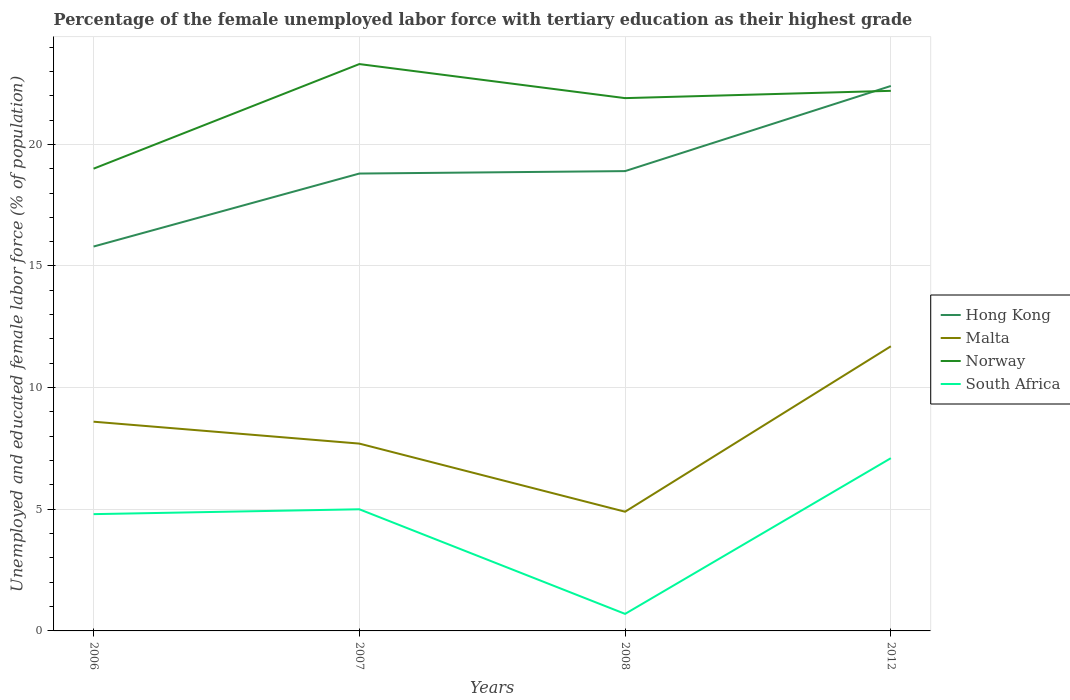Does the line corresponding to Malta intersect with the line corresponding to South Africa?
Keep it short and to the point. No. What is the total percentage of the unemployed female labor force with tertiary education in Malta in the graph?
Offer a terse response. -3.1. What is the difference between the highest and the second highest percentage of the unemployed female labor force with tertiary education in Malta?
Your response must be concise. 6.8. What is the difference between the highest and the lowest percentage of the unemployed female labor force with tertiary education in Hong Kong?
Ensure brevity in your answer.  1. How many lines are there?
Give a very brief answer. 4. Are the values on the major ticks of Y-axis written in scientific E-notation?
Your answer should be very brief. No. Where does the legend appear in the graph?
Your response must be concise. Center right. How many legend labels are there?
Offer a terse response. 4. How are the legend labels stacked?
Ensure brevity in your answer.  Vertical. What is the title of the graph?
Make the answer very short. Percentage of the female unemployed labor force with tertiary education as their highest grade. What is the label or title of the Y-axis?
Your answer should be compact. Unemployed and educated female labor force (% of population). What is the Unemployed and educated female labor force (% of population) in Hong Kong in 2006?
Your answer should be compact. 15.8. What is the Unemployed and educated female labor force (% of population) of Malta in 2006?
Your answer should be very brief. 8.6. What is the Unemployed and educated female labor force (% of population) of South Africa in 2006?
Your answer should be compact. 4.8. What is the Unemployed and educated female labor force (% of population) of Hong Kong in 2007?
Ensure brevity in your answer.  18.8. What is the Unemployed and educated female labor force (% of population) in Malta in 2007?
Keep it short and to the point. 7.7. What is the Unemployed and educated female labor force (% of population) of Norway in 2007?
Offer a very short reply. 23.3. What is the Unemployed and educated female labor force (% of population) in South Africa in 2007?
Offer a terse response. 5. What is the Unemployed and educated female labor force (% of population) in Hong Kong in 2008?
Offer a very short reply. 18.9. What is the Unemployed and educated female labor force (% of population) in Malta in 2008?
Your response must be concise. 4.9. What is the Unemployed and educated female labor force (% of population) of Norway in 2008?
Offer a terse response. 21.9. What is the Unemployed and educated female labor force (% of population) in South Africa in 2008?
Make the answer very short. 0.7. What is the Unemployed and educated female labor force (% of population) in Hong Kong in 2012?
Provide a succinct answer. 22.4. What is the Unemployed and educated female labor force (% of population) in Malta in 2012?
Provide a succinct answer. 11.7. What is the Unemployed and educated female labor force (% of population) of Norway in 2012?
Your answer should be compact. 22.2. What is the Unemployed and educated female labor force (% of population) of South Africa in 2012?
Keep it short and to the point. 7.1. Across all years, what is the maximum Unemployed and educated female labor force (% of population) of Hong Kong?
Give a very brief answer. 22.4. Across all years, what is the maximum Unemployed and educated female labor force (% of population) in Malta?
Provide a succinct answer. 11.7. Across all years, what is the maximum Unemployed and educated female labor force (% of population) of Norway?
Offer a very short reply. 23.3. Across all years, what is the maximum Unemployed and educated female labor force (% of population) of South Africa?
Offer a terse response. 7.1. Across all years, what is the minimum Unemployed and educated female labor force (% of population) in Hong Kong?
Your response must be concise. 15.8. Across all years, what is the minimum Unemployed and educated female labor force (% of population) in Malta?
Offer a very short reply. 4.9. Across all years, what is the minimum Unemployed and educated female labor force (% of population) of South Africa?
Offer a very short reply. 0.7. What is the total Unemployed and educated female labor force (% of population) in Hong Kong in the graph?
Offer a very short reply. 75.9. What is the total Unemployed and educated female labor force (% of population) of Malta in the graph?
Your answer should be very brief. 32.9. What is the total Unemployed and educated female labor force (% of population) in Norway in the graph?
Provide a succinct answer. 86.4. What is the total Unemployed and educated female labor force (% of population) of South Africa in the graph?
Your answer should be very brief. 17.6. What is the difference between the Unemployed and educated female labor force (% of population) of Malta in 2006 and that in 2007?
Offer a very short reply. 0.9. What is the difference between the Unemployed and educated female labor force (% of population) of Norway in 2006 and that in 2007?
Offer a very short reply. -4.3. What is the difference between the Unemployed and educated female labor force (% of population) in Hong Kong in 2006 and that in 2008?
Make the answer very short. -3.1. What is the difference between the Unemployed and educated female labor force (% of population) in Malta in 2006 and that in 2008?
Give a very brief answer. 3.7. What is the difference between the Unemployed and educated female labor force (% of population) in South Africa in 2006 and that in 2008?
Make the answer very short. 4.1. What is the difference between the Unemployed and educated female labor force (% of population) of Hong Kong in 2006 and that in 2012?
Keep it short and to the point. -6.6. What is the difference between the Unemployed and educated female labor force (% of population) of South Africa in 2006 and that in 2012?
Offer a very short reply. -2.3. What is the difference between the Unemployed and educated female labor force (% of population) of Hong Kong in 2007 and that in 2008?
Give a very brief answer. -0.1. What is the difference between the Unemployed and educated female labor force (% of population) in Malta in 2007 and that in 2008?
Offer a very short reply. 2.8. What is the difference between the Unemployed and educated female labor force (% of population) in South Africa in 2007 and that in 2012?
Your answer should be compact. -2.1. What is the difference between the Unemployed and educated female labor force (% of population) of Hong Kong in 2008 and that in 2012?
Your response must be concise. -3.5. What is the difference between the Unemployed and educated female labor force (% of population) of Malta in 2008 and that in 2012?
Make the answer very short. -6.8. What is the difference between the Unemployed and educated female labor force (% of population) of Norway in 2008 and that in 2012?
Keep it short and to the point. -0.3. What is the difference between the Unemployed and educated female labor force (% of population) of Hong Kong in 2006 and the Unemployed and educated female labor force (% of population) of Malta in 2007?
Offer a very short reply. 8.1. What is the difference between the Unemployed and educated female labor force (% of population) in Hong Kong in 2006 and the Unemployed and educated female labor force (% of population) in South Africa in 2007?
Give a very brief answer. 10.8. What is the difference between the Unemployed and educated female labor force (% of population) of Malta in 2006 and the Unemployed and educated female labor force (% of population) of Norway in 2007?
Provide a succinct answer. -14.7. What is the difference between the Unemployed and educated female labor force (% of population) of Malta in 2006 and the Unemployed and educated female labor force (% of population) of South Africa in 2007?
Your response must be concise. 3.6. What is the difference between the Unemployed and educated female labor force (% of population) of Norway in 2006 and the Unemployed and educated female labor force (% of population) of South Africa in 2007?
Offer a terse response. 14. What is the difference between the Unemployed and educated female labor force (% of population) in Malta in 2006 and the Unemployed and educated female labor force (% of population) in Norway in 2008?
Offer a terse response. -13.3. What is the difference between the Unemployed and educated female labor force (% of population) of Hong Kong in 2006 and the Unemployed and educated female labor force (% of population) of Malta in 2012?
Offer a very short reply. 4.1. What is the difference between the Unemployed and educated female labor force (% of population) in Hong Kong in 2006 and the Unemployed and educated female labor force (% of population) in South Africa in 2012?
Provide a short and direct response. 8.7. What is the difference between the Unemployed and educated female labor force (% of population) in Malta in 2006 and the Unemployed and educated female labor force (% of population) in Norway in 2012?
Your answer should be compact. -13.6. What is the difference between the Unemployed and educated female labor force (% of population) in Malta in 2006 and the Unemployed and educated female labor force (% of population) in South Africa in 2012?
Your answer should be very brief. 1.5. What is the difference between the Unemployed and educated female labor force (% of population) in Hong Kong in 2007 and the Unemployed and educated female labor force (% of population) in South Africa in 2008?
Ensure brevity in your answer.  18.1. What is the difference between the Unemployed and educated female labor force (% of population) in Malta in 2007 and the Unemployed and educated female labor force (% of population) in South Africa in 2008?
Ensure brevity in your answer.  7. What is the difference between the Unemployed and educated female labor force (% of population) in Norway in 2007 and the Unemployed and educated female labor force (% of population) in South Africa in 2008?
Give a very brief answer. 22.6. What is the difference between the Unemployed and educated female labor force (% of population) in Hong Kong in 2007 and the Unemployed and educated female labor force (% of population) in Norway in 2012?
Offer a very short reply. -3.4. What is the difference between the Unemployed and educated female labor force (% of population) of Norway in 2007 and the Unemployed and educated female labor force (% of population) of South Africa in 2012?
Your response must be concise. 16.2. What is the difference between the Unemployed and educated female labor force (% of population) of Hong Kong in 2008 and the Unemployed and educated female labor force (% of population) of South Africa in 2012?
Provide a succinct answer. 11.8. What is the difference between the Unemployed and educated female labor force (% of population) in Malta in 2008 and the Unemployed and educated female labor force (% of population) in Norway in 2012?
Offer a very short reply. -17.3. What is the difference between the Unemployed and educated female labor force (% of population) of Malta in 2008 and the Unemployed and educated female labor force (% of population) of South Africa in 2012?
Your answer should be very brief. -2.2. What is the difference between the Unemployed and educated female labor force (% of population) in Norway in 2008 and the Unemployed and educated female labor force (% of population) in South Africa in 2012?
Make the answer very short. 14.8. What is the average Unemployed and educated female labor force (% of population) of Hong Kong per year?
Offer a terse response. 18.98. What is the average Unemployed and educated female labor force (% of population) in Malta per year?
Provide a succinct answer. 8.22. What is the average Unemployed and educated female labor force (% of population) of Norway per year?
Provide a short and direct response. 21.6. In the year 2006, what is the difference between the Unemployed and educated female labor force (% of population) in Hong Kong and Unemployed and educated female labor force (% of population) in Malta?
Provide a short and direct response. 7.2. In the year 2006, what is the difference between the Unemployed and educated female labor force (% of population) of Hong Kong and Unemployed and educated female labor force (% of population) of South Africa?
Offer a terse response. 11. In the year 2006, what is the difference between the Unemployed and educated female labor force (% of population) of Malta and Unemployed and educated female labor force (% of population) of South Africa?
Keep it short and to the point. 3.8. In the year 2007, what is the difference between the Unemployed and educated female labor force (% of population) in Hong Kong and Unemployed and educated female labor force (% of population) in Malta?
Your answer should be compact. 11.1. In the year 2007, what is the difference between the Unemployed and educated female labor force (% of population) of Hong Kong and Unemployed and educated female labor force (% of population) of Norway?
Offer a very short reply. -4.5. In the year 2007, what is the difference between the Unemployed and educated female labor force (% of population) of Hong Kong and Unemployed and educated female labor force (% of population) of South Africa?
Provide a succinct answer. 13.8. In the year 2007, what is the difference between the Unemployed and educated female labor force (% of population) in Malta and Unemployed and educated female labor force (% of population) in Norway?
Keep it short and to the point. -15.6. In the year 2007, what is the difference between the Unemployed and educated female labor force (% of population) in Malta and Unemployed and educated female labor force (% of population) in South Africa?
Keep it short and to the point. 2.7. In the year 2008, what is the difference between the Unemployed and educated female labor force (% of population) in Hong Kong and Unemployed and educated female labor force (% of population) in Malta?
Your response must be concise. 14. In the year 2008, what is the difference between the Unemployed and educated female labor force (% of population) in Hong Kong and Unemployed and educated female labor force (% of population) in South Africa?
Make the answer very short. 18.2. In the year 2008, what is the difference between the Unemployed and educated female labor force (% of population) in Malta and Unemployed and educated female labor force (% of population) in Norway?
Your answer should be very brief. -17. In the year 2008, what is the difference between the Unemployed and educated female labor force (% of population) in Norway and Unemployed and educated female labor force (% of population) in South Africa?
Your answer should be very brief. 21.2. In the year 2012, what is the difference between the Unemployed and educated female labor force (% of population) of Hong Kong and Unemployed and educated female labor force (% of population) of Malta?
Your answer should be compact. 10.7. In the year 2012, what is the difference between the Unemployed and educated female labor force (% of population) in Hong Kong and Unemployed and educated female labor force (% of population) in South Africa?
Your answer should be compact. 15.3. In the year 2012, what is the difference between the Unemployed and educated female labor force (% of population) of Malta and Unemployed and educated female labor force (% of population) of Norway?
Make the answer very short. -10.5. In the year 2012, what is the difference between the Unemployed and educated female labor force (% of population) in Malta and Unemployed and educated female labor force (% of population) in South Africa?
Your answer should be very brief. 4.6. What is the ratio of the Unemployed and educated female labor force (% of population) in Hong Kong in 2006 to that in 2007?
Your response must be concise. 0.84. What is the ratio of the Unemployed and educated female labor force (% of population) in Malta in 2006 to that in 2007?
Offer a very short reply. 1.12. What is the ratio of the Unemployed and educated female labor force (% of population) of Norway in 2006 to that in 2007?
Provide a succinct answer. 0.82. What is the ratio of the Unemployed and educated female labor force (% of population) of Hong Kong in 2006 to that in 2008?
Provide a succinct answer. 0.84. What is the ratio of the Unemployed and educated female labor force (% of population) in Malta in 2006 to that in 2008?
Your answer should be very brief. 1.76. What is the ratio of the Unemployed and educated female labor force (% of population) in Norway in 2006 to that in 2008?
Provide a short and direct response. 0.87. What is the ratio of the Unemployed and educated female labor force (% of population) in South Africa in 2006 to that in 2008?
Your answer should be very brief. 6.86. What is the ratio of the Unemployed and educated female labor force (% of population) in Hong Kong in 2006 to that in 2012?
Your answer should be compact. 0.71. What is the ratio of the Unemployed and educated female labor force (% of population) of Malta in 2006 to that in 2012?
Make the answer very short. 0.73. What is the ratio of the Unemployed and educated female labor force (% of population) of Norway in 2006 to that in 2012?
Your answer should be very brief. 0.86. What is the ratio of the Unemployed and educated female labor force (% of population) in South Africa in 2006 to that in 2012?
Offer a terse response. 0.68. What is the ratio of the Unemployed and educated female labor force (% of population) of Hong Kong in 2007 to that in 2008?
Your answer should be very brief. 0.99. What is the ratio of the Unemployed and educated female labor force (% of population) in Malta in 2007 to that in 2008?
Your answer should be very brief. 1.57. What is the ratio of the Unemployed and educated female labor force (% of population) of Norway in 2007 to that in 2008?
Keep it short and to the point. 1.06. What is the ratio of the Unemployed and educated female labor force (% of population) of South Africa in 2007 to that in 2008?
Your answer should be very brief. 7.14. What is the ratio of the Unemployed and educated female labor force (% of population) in Hong Kong in 2007 to that in 2012?
Your response must be concise. 0.84. What is the ratio of the Unemployed and educated female labor force (% of population) in Malta in 2007 to that in 2012?
Keep it short and to the point. 0.66. What is the ratio of the Unemployed and educated female labor force (% of population) of Norway in 2007 to that in 2012?
Make the answer very short. 1.05. What is the ratio of the Unemployed and educated female labor force (% of population) in South Africa in 2007 to that in 2012?
Your response must be concise. 0.7. What is the ratio of the Unemployed and educated female labor force (% of population) in Hong Kong in 2008 to that in 2012?
Offer a terse response. 0.84. What is the ratio of the Unemployed and educated female labor force (% of population) of Malta in 2008 to that in 2012?
Offer a terse response. 0.42. What is the ratio of the Unemployed and educated female labor force (% of population) in Norway in 2008 to that in 2012?
Keep it short and to the point. 0.99. What is the ratio of the Unemployed and educated female labor force (% of population) in South Africa in 2008 to that in 2012?
Your answer should be compact. 0.1. What is the difference between the highest and the second highest Unemployed and educated female labor force (% of population) in Malta?
Make the answer very short. 3.1. What is the difference between the highest and the second highest Unemployed and educated female labor force (% of population) of Norway?
Give a very brief answer. 1.1. What is the difference between the highest and the second highest Unemployed and educated female labor force (% of population) of South Africa?
Ensure brevity in your answer.  2.1. What is the difference between the highest and the lowest Unemployed and educated female labor force (% of population) in Norway?
Give a very brief answer. 4.3. What is the difference between the highest and the lowest Unemployed and educated female labor force (% of population) of South Africa?
Ensure brevity in your answer.  6.4. 